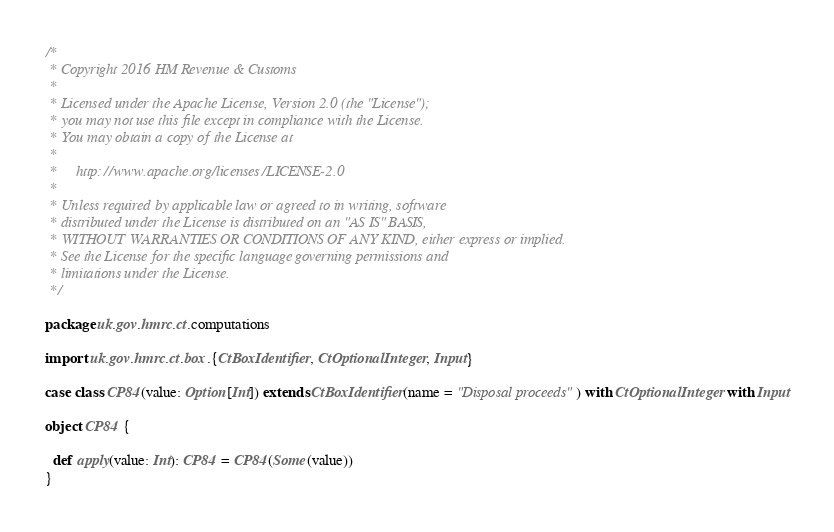Convert code to text. <code><loc_0><loc_0><loc_500><loc_500><_Scala_>/*
 * Copyright 2016 HM Revenue & Customs
 *
 * Licensed under the Apache License, Version 2.0 (the "License");
 * you may not use this file except in compliance with the License.
 * You may obtain a copy of the License at
 *
 *     http://www.apache.org/licenses/LICENSE-2.0
 *
 * Unless required by applicable law or agreed to in writing, software
 * distributed under the License is distributed on an "AS IS" BASIS,
 * WITHOUT WARRANTIES OR CONDITIONS OF ANY KIND, either express or implied.
 * See the License for the specific language governing permissions and
 * limitations under the License.
 */

package uk.gov.hmrc.ct.computations

import uk.gov.hmrc.ct.box.{CtBoxIdentifier, CtOptionalInteger, Input}

case class CP84(value: Option[Int]) extends CtBoxIdentifier(name = "Disposal proceeds") with CtOptionalInteger with Input

object CP84 {

  def apply(value: Int): CP84 = CP84(Some(value))
}
</code> 